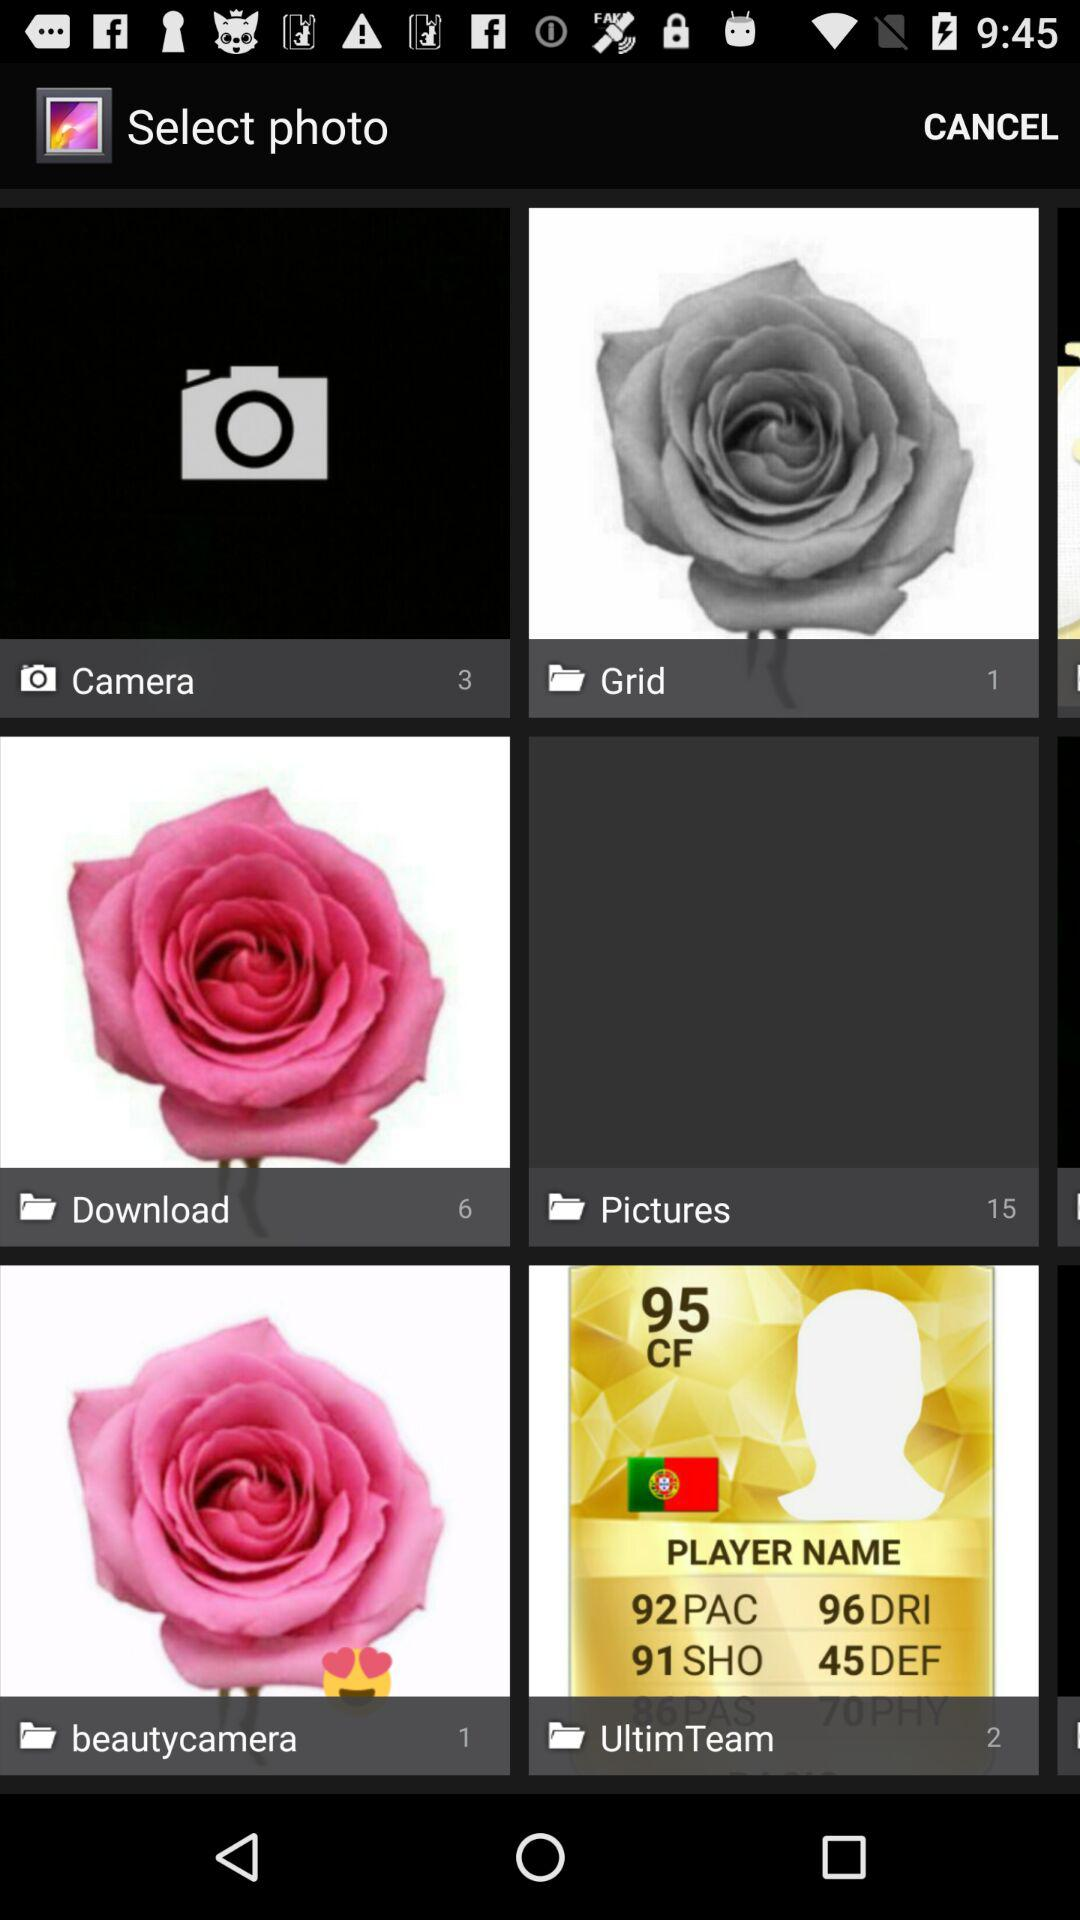What is the total number of images in the "Camera" folder? The total number of images in the "Camera" folder is 3. 